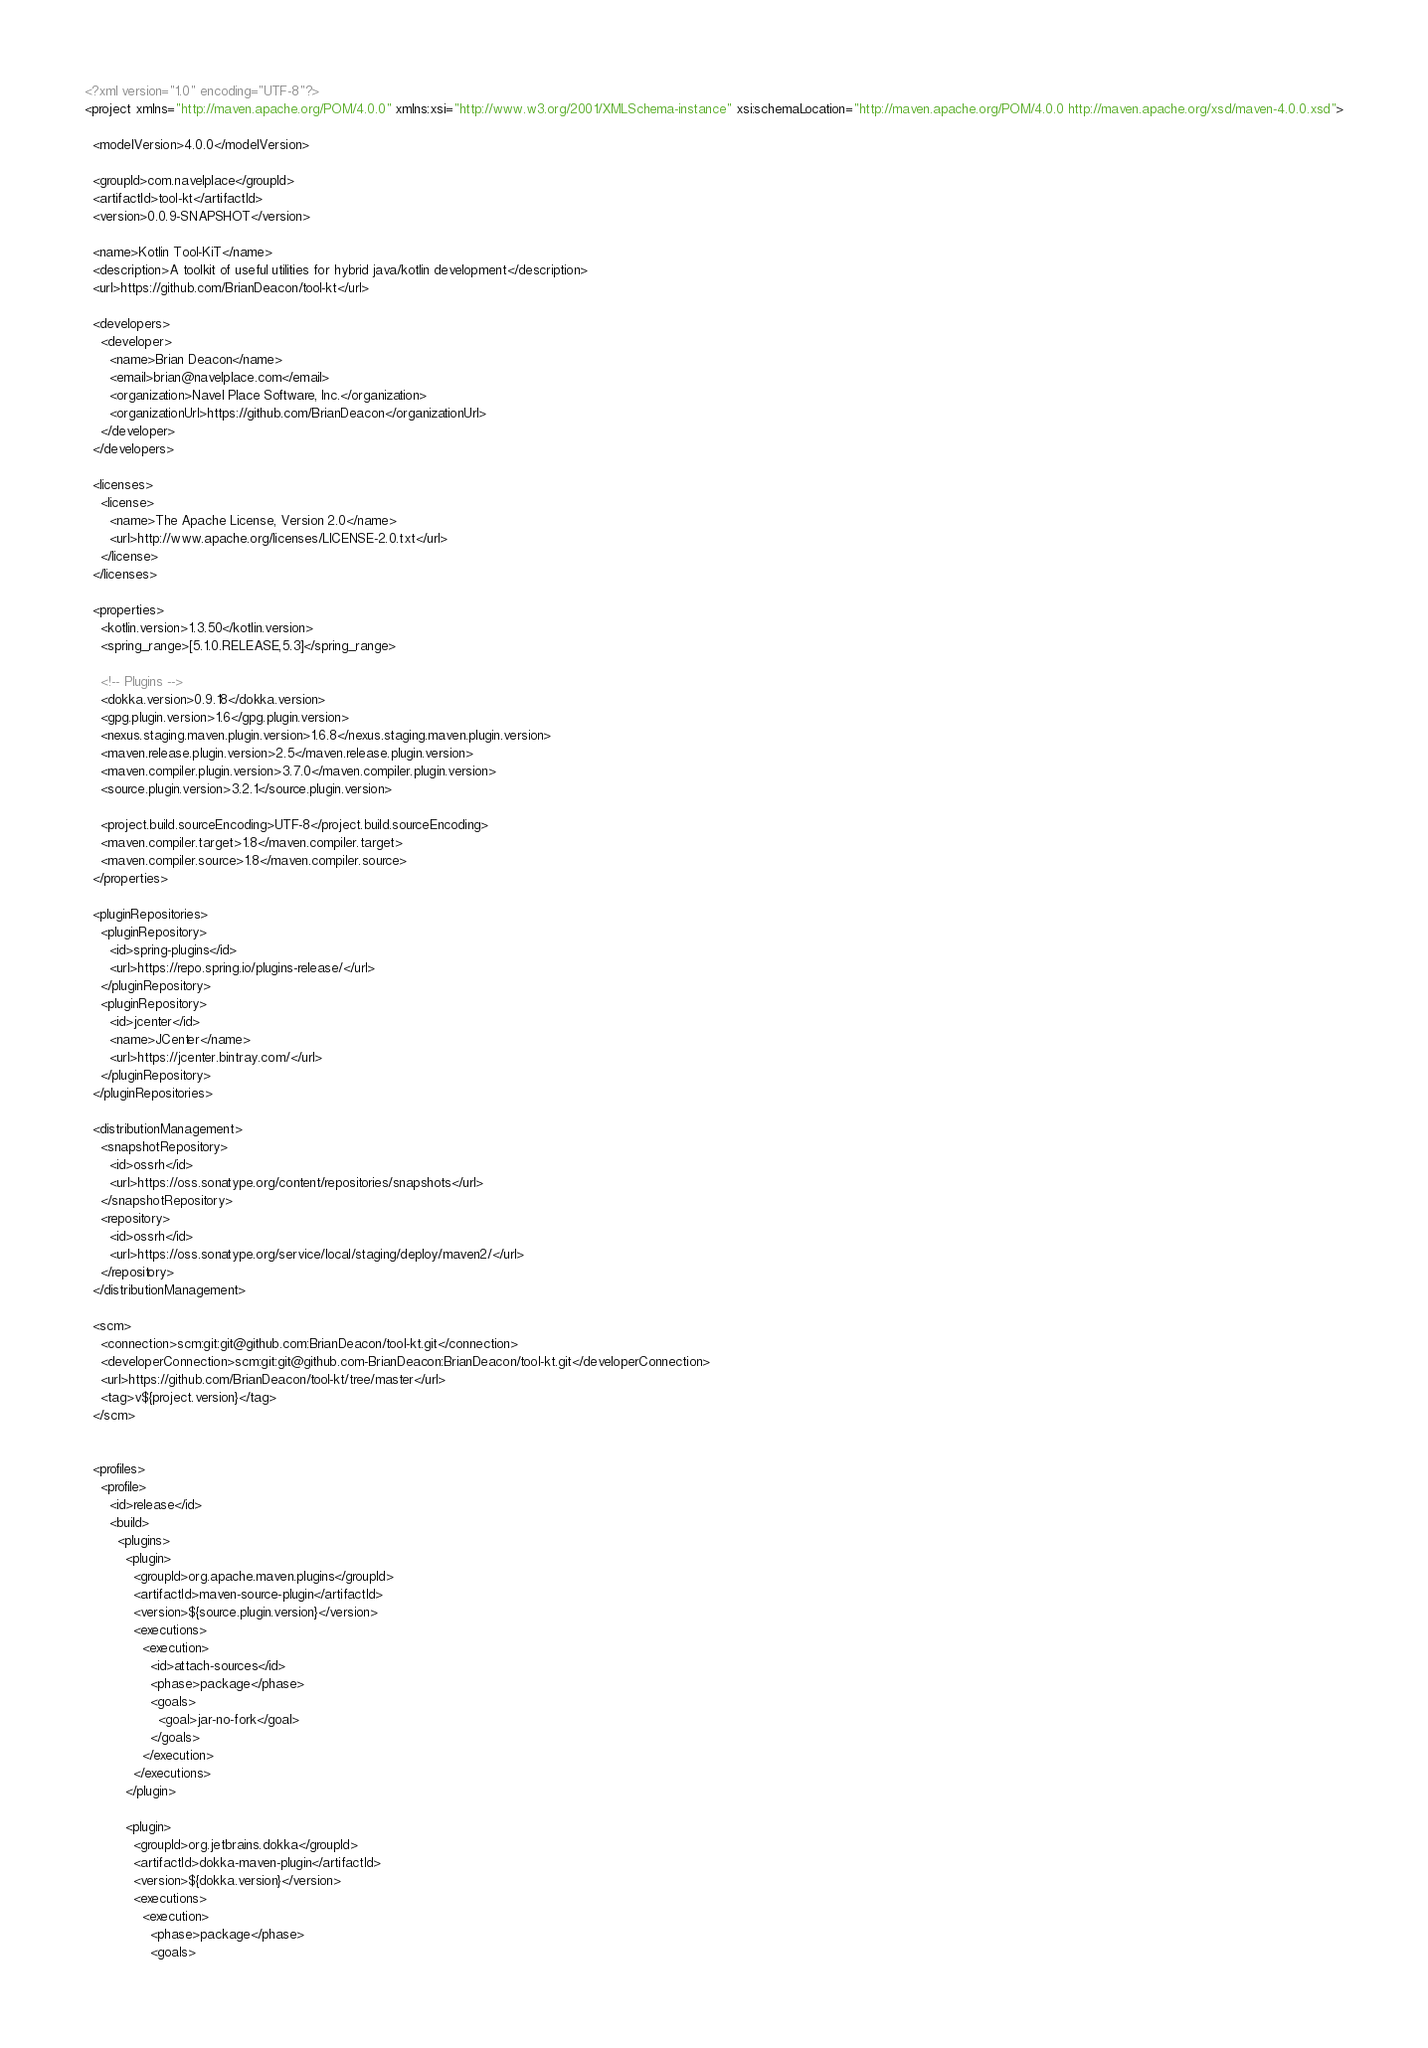Convert code to text. <code><loc_0><loc_0><loc_500><loc_500><_XML_><?xml version="1.0" encoding="UTF-8"?>
<project xmlns="http://maven.apache.org/POM/4.0.0" xmlns:xsi="http://www.w3.org/2001/XMLSchema-instance" xsi:schemaLocation="http://maven.apache.org/POM/4.0.0 http://maven.apache.org/xsd/maven-4.0.0.xsd">

  <modelVersion>4.0.0</modelVersion>

  <groupId>com.navelplace</groupId>
  <artifactId>tool-kt</artifactId>
  <version>0.0.9-SNAPSHOT</version>

  <name>Kotlin Tool-KiT</name>
  <description>A toolkit of useful utilities for hybrid java/kotlin development</description>
  <url>https://github.com/BrianDeacon/tool-kt</url>

  <developers>
    <developer>
      <name>Brian Deacon</name>
      <email>brian@navelplace.com</email>
      <organization>Navel Place Software, Inc.</organization>
      <organizationUrl>https://github.com/BrianDeacon</organizationUrl>
    </developer>
  </developers>

  <licenses>
    <license>
      <name>The Apache License, Version 2.0</name>
      <url>http://www.apache.org/licenses/LICENSE-2.0.txt</url>
    </license>
  </licenses>

  <properties>
    <kotlin.version>1.3.50</kotlin.version>
    <spring_range>[5.1.0.RELEASE,5.3]</spring_range>

    <!-- Plugins -->
    <dokka.version>0.9.18</dokka.version>
    <gpg.plugin.version>1.6</gpg.plugin.version>
    <nexus.staging.maven.plugin.version>1.6.8</nexus.staging.maven.plugin.version>
    <maven.release.plugin.version>2.5</maven.release.plugin.version>
    <maven.compiler.plugin.version>3.7.0</maven.compiler.plugin.version>
    <source.plugin.version>3.2.1</source.plugin.version>

    <project.build.sourceEncoding>UTF-8</project.build.sourceEncoding>
    <maven.compiler.target>1.8</maven.compiler.target>
    <maven.compiler.source>1.8</maven.compiler.source>
  </properties>

  <pluginRepositories>
    <pluginRepository>
      <id>spring-plugins</id>
      <url>https://repo.spring.io/plugins-release/</url>
    </pluginRepository>
    <pluginRepository>
      <id>jcenter</id>
      <name>JCenter</name>
      <url>https://jcenter.bintray.com/</url>
    </pluginRepository>
  </pluginRepositories>

  <distributionManagement>
    <snapshotRepository>
      <id>ossrh</id>
      <url>https://oss.sonatype.org/content/repositories/snapshots</url>
    </snapshotRepository>
    <repository>
      <id>ossrh</id>
      <url>https://oss.sonatype.org/service/local/staging/deploy/maven2/</url>
    </repository>
  </distributionManagement>

  <scm>
    <connection>scm:git:git@github.com:BrianDeacon/tool-kt.git</connection>
    <developerConnection>scm:git:git@github.com-BrianDeacon:BrianDeacon/tool-kt.git</developerConnection>
    <url>https://github.com/BrianDeacon/tool-kt/tree/master</url>
    <tag>v${project.version}</tag>
  </scm>


  <profiles>
    <profile>
      <id>release</id>
      <build>
        <plugins>
          <plugin>
            <groupId>org.apache.maven.plugins</groupId>
            <artifactId>maven-source-plugin</artifactId>
            <version>${source.plugin.version}</version>
            <executions>
              <execution>
                <id>attach-sources</id>
                <phase>package</phase>
                <goals>
                  <goal>jar-no-fork</goal>
                </goals>
              </execution>
            </executions>
          </plugin>
          
          <plugin>
            <groupId>org.jetbrains.dokka</groupId>
            <artifactId>dokka-maven-plugin</artifactId>
            <version>${dokka.version}</version>
            <executions>
              <execution>
                <phase>package</phase>
                <goals></code> 